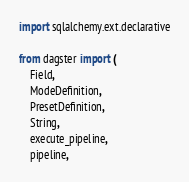<code> <loc_0><loc_0><loc_500><loc_500><_Python_>import sqlalchemy.ext.declarative

from dagster import (
    Field,
    ModeDefinition,
    PresetDefinition,
    String,
    execute_pipeline,
    pipeline,</code> 